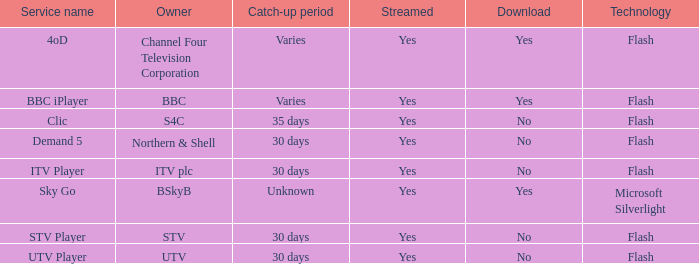What does the catch-up duration for utv entail? 30 days. 